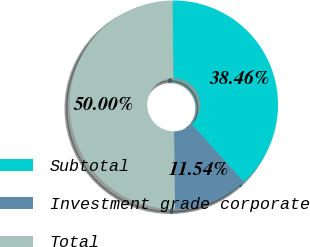Convert chart. <chart><loc_0><loc_0><loc_500><loc_500><pie_chart><fcel>Subtotal<fcel>Investment grade corporate<fcel>Total<nl><fcel>38.46%<fcel>11.54%<fcel>50.0%<nl></chart> 